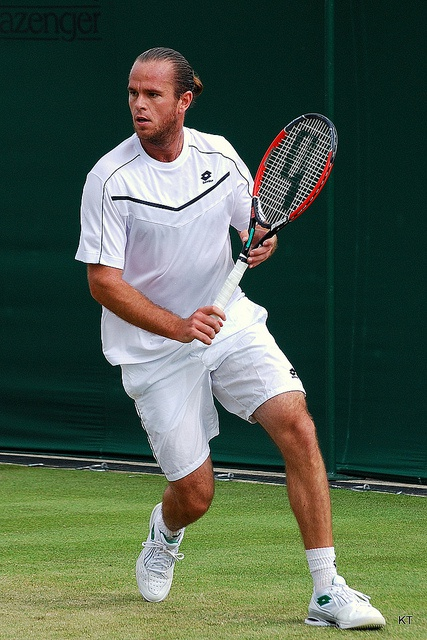Describe the objects in this image and their specific colors. I can see people in black, lightgray, darkgray, and maroon tones and tennis racket in black, lightgray, darkgray, and gray tones in this image. 